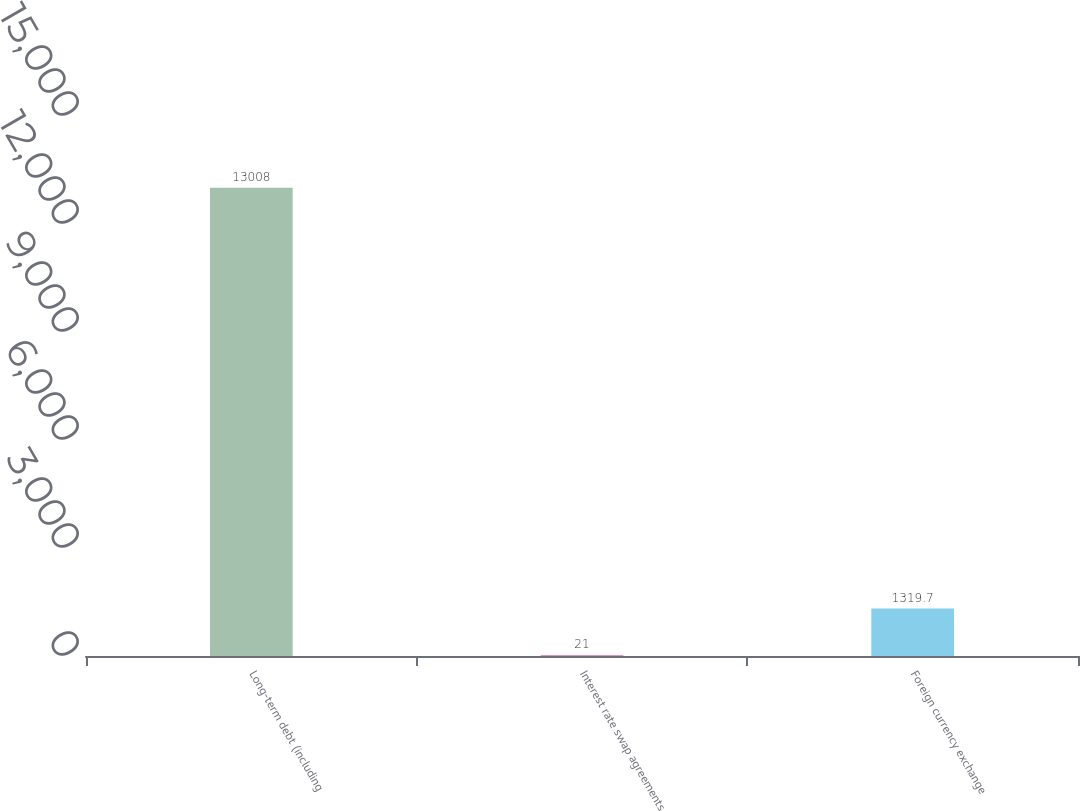Convert chart. <chart><loc_0><loc_0><loc_500><loc_500><bar_chart><fcel>Long-term debt (including<fcel>Interest rate swap agreements<fcel>Foreign currency exchange<nl><fcel>13008<fcel>21<fcel>1319.7<nl></chart> 